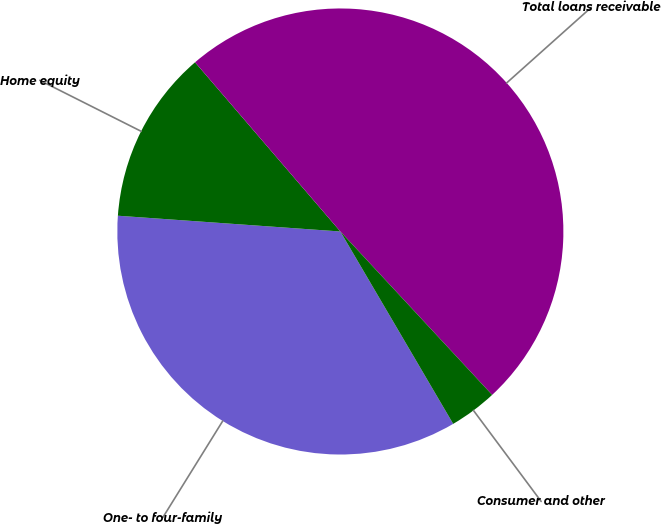Convert chart. <chart><loc_0><loc_0><loc_500><loc_500><pie_chart><fcel>One- to four-family<fcel>Home equity<fcel>Total loans receivable<fcel>Consumer and other<nl><fcel>34.57%<fcel>12.58%<fcel>49.38%<fcel>3.47%<nl></chart> 